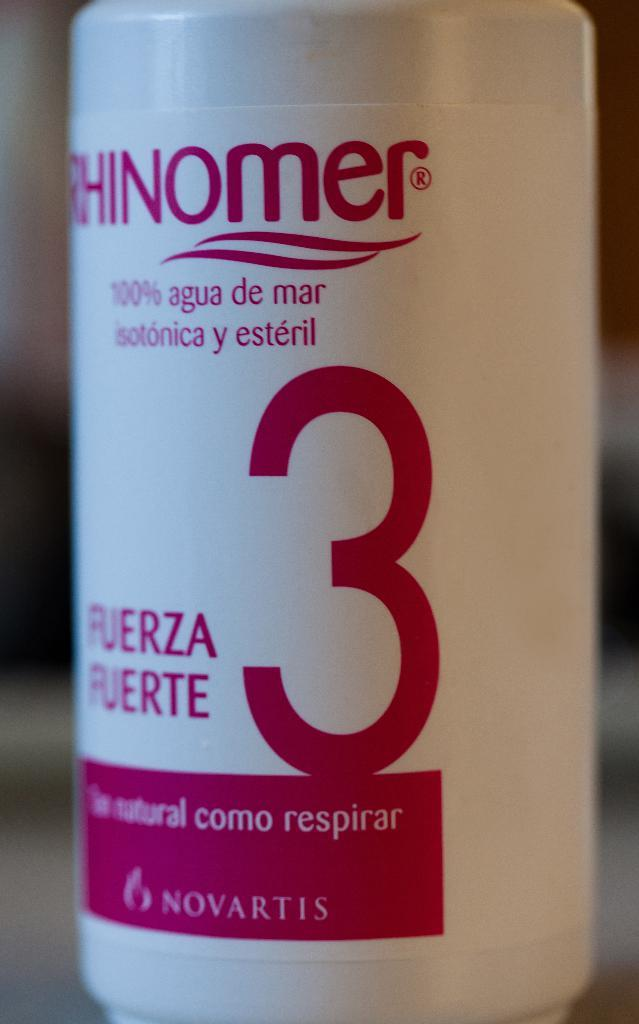<image>
Render a clear and concise summary of the photo. The bottle has a large number three on it written in red 